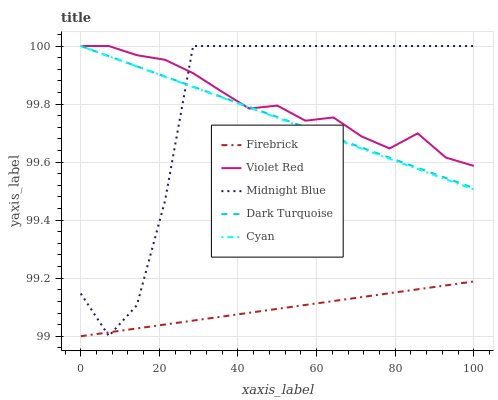Does Firebrick have the minimum area under the curve?
Answer yes or no. Yes. Does Violet Red have the maximum area under the curve?
Answer yes or no. Yes. Does Cyan have the minimum area under the curve?
Answer yes or no. No. Does Cyan have the maximum area under the curve?
Answer yes or no. No. Is Dark Turquoise the smoothest?
Answer yes or no. Yes. Is Midnight Blue the roughest?
Answer yes or no. Yes. Is Firebrick the smoothest?
Answer yes or no. No. Is Firebrick the roughest?
Answer yes or no. No. Does Firebrick have the lowest value?
Answer yes or no. Yes. Does Cyan have the lowest value?
Answer yes or no. No. Does Midnight Blue have the highest value?
Answer yes or no. Yes. Does Firebrick have the highest value?
Answer yes or no. No. Is Firebrick less than Dark Turquoise?
Answer yes or no. Yes. Is Violet Red greater than Firebrick?
Answer yes or no. Yes. Does Dark Turquoise intersect Midnight Blue?
Answer yes or no. Yes. Is Dark Turquoise less than Midnight Blue?
Answer yes or no. No. Is Dark Turquoise greater than Midnight Blue?
Answer yes or no. No. Does Firebrick intersect Dark Turquoise?
Answer yes or no. No. 